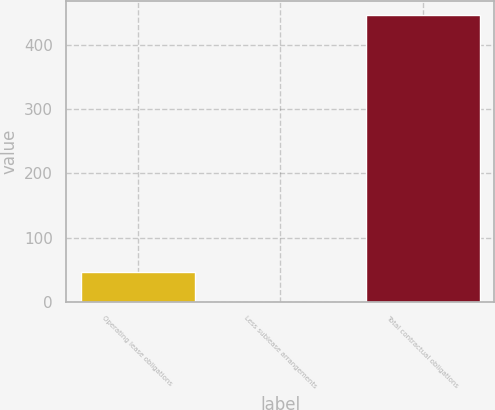<chart> <loc_0><loc_0><loc_500><loc_500><bar_chart><fcel>Operating lease obligations<fcel>Less sublease arrangements<fcel>Total contractual obligations<nl><fcel>47<fcel>0.6<fcel>446.4<nl></chart> 